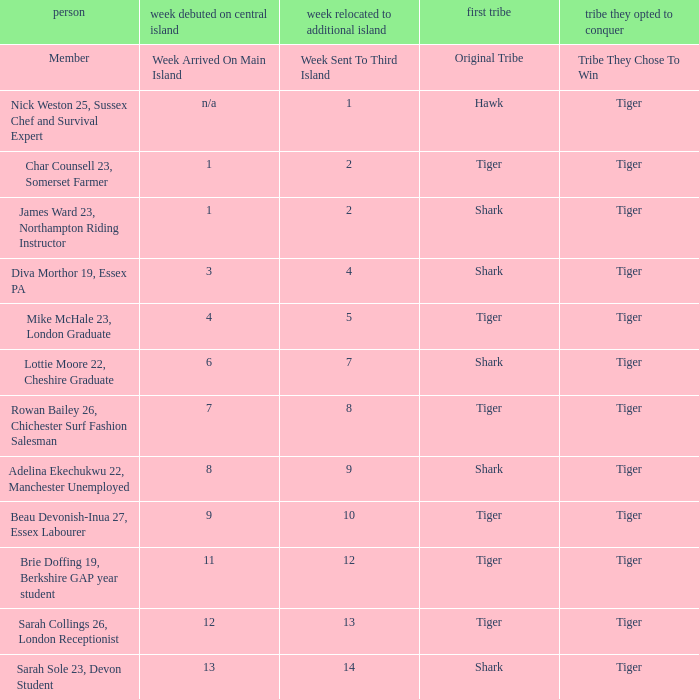What week did the member who's original tribe was shark and who was sent to the third island on week 14 arrive on the main island? 13.0. 